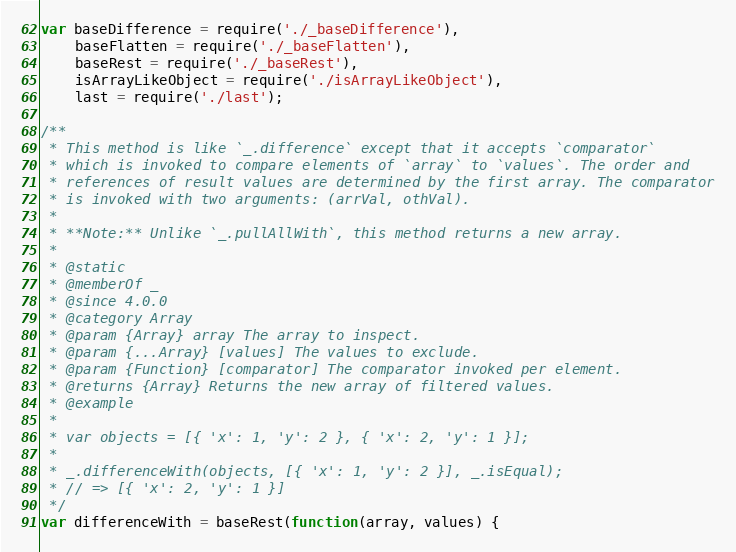Convert code to text. <code><loc_0><loc_0><loc_500><loc_500><_JavaScript_>var baseDifference = require('./_baseDifference'),
    baseFlatten = require('./_baseFlatten'),
    baseRest = require('./_baseRest'),
    isArrayLikeObject = require('./isArrayLikeObject'),
    last = require('./last');

/**
 * This method is like `_.difference` except that it accepts `comparator`
 * which is invoked to compare elements of `array` to `values`. The order and
 * references of result values are determined by the first array. The comparator
 * is invoked with two arguments: (arrVal, othVal).
 *
 * **Note:** Unlike `_.pullAllWith`, this method returns a new array.
 *
 * @static
 * @memberOf _
 * @since 4.0.0
 * @category Array
 * @param {Array} array The array to inspect.
 * @param {...Array} [values] The values to exclude.
 * @param {Function} [comparator] The comparator invoked per element.
 * @returns {Array} Returns the new array of filtered values.
 * @example
 *
 * var objects = [{ 'x': 1, 'y': 2 }, { 'x': 2, 'y': 1 }];
 *
 * _.differenceWith(objects, [{ 'x': 1, 'y': 2 }], _.isEqual);
 * // => [{ 'x': 2, 'y': 1 }]
 */
var differenceWith = baseRest(function(array, values) {</code> 